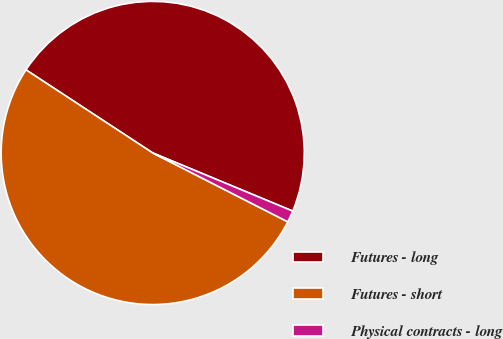<chart> <loc_0><loc_0><loc_500><loc_500><pie_chart><fcel>Futures - long<fcel>Futures - short<fcel>Physical contracts - long<nl><fcel>47.03%<fcel>51.73%<fcel>1.24%<nl></chart> 